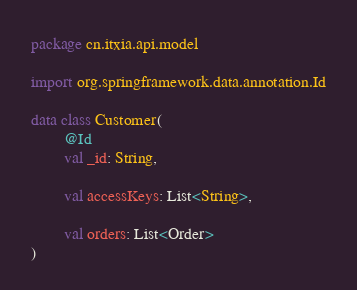<code> <loc_0><loc_0><loc_500><loc_500><_Kotlin_>package cn.itxia.api.model

import org.springframework.data.annotation.Id

data class Customer(
        @Id
        val _id: String,

        val accessKeys: List<String>,

        val orders: List<Order>
)</code> 